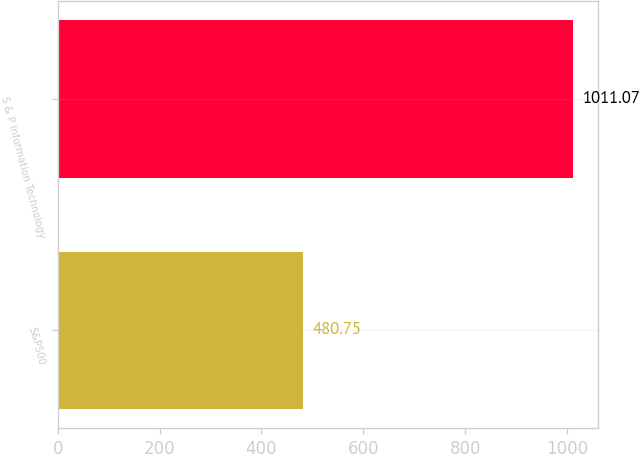<chart> <loc_0><loc_0><loc_500><loc_500><bar_chart><fcel>S&P500<fcel>S & P Information Technology<nl><fcel>480.75<fcel>1011.07<nl></chart> 